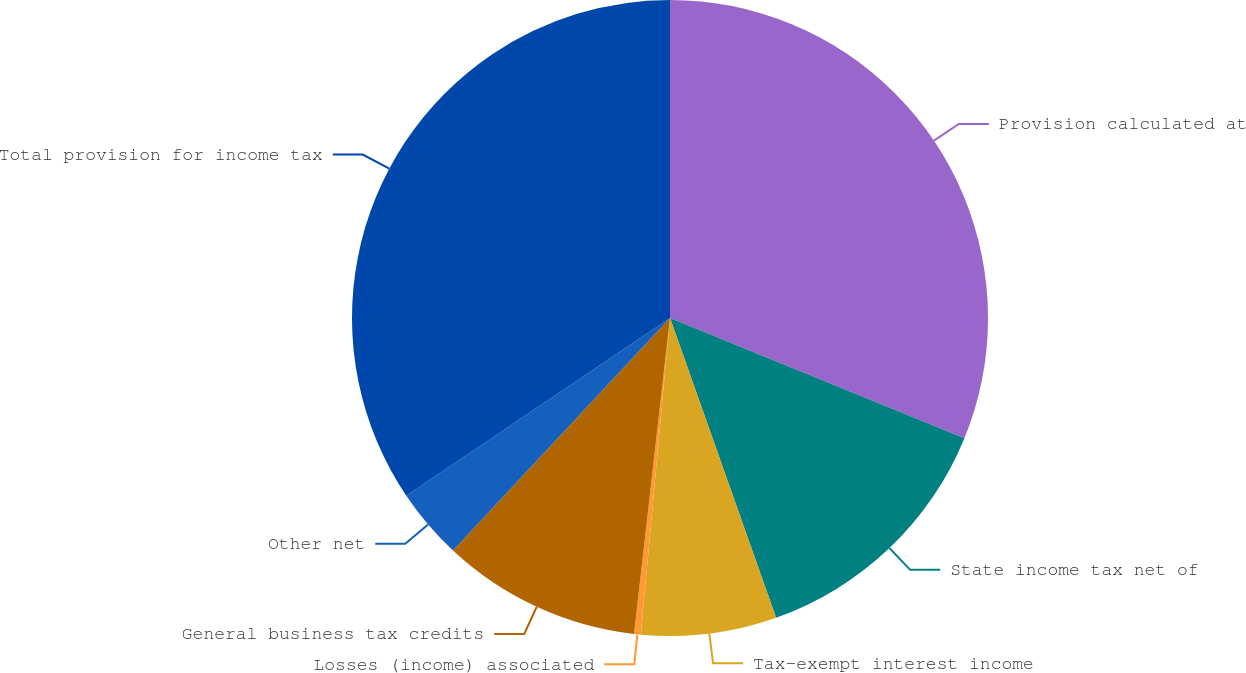Convert chart. <chart><loc_0><loc_0><loc_500><loc_500><pie_chart><fcel>Provision calculated at<fcel>State income tax net of<fcel>Tax-exempt interest income<fcel>Losses (income) associated<fcel>General business tax credits<fcel>Other net<fcel>Total provision for income tax<nl><fcel>31.17%<fcel>13.42%<fcel>6.88%<fcel>0.34%<fcel>10.15%<fcel>3.61%<fcel>34.44%<nl></chart> 